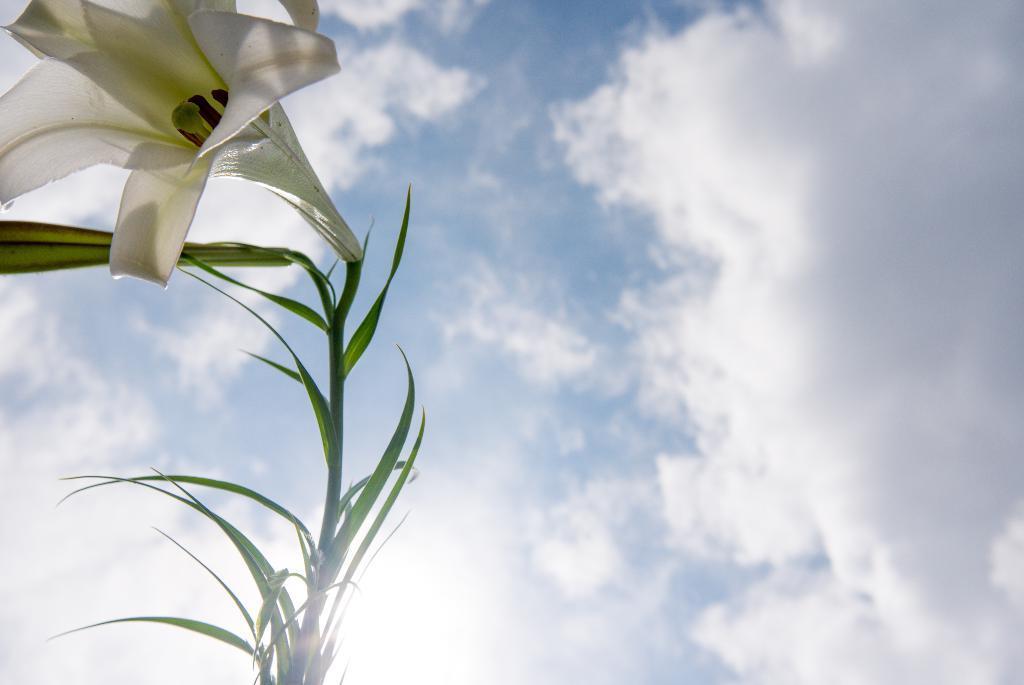Please provide a concise description of this image. In this image in front there is a plant with the flower on it. In the background there is sky. 